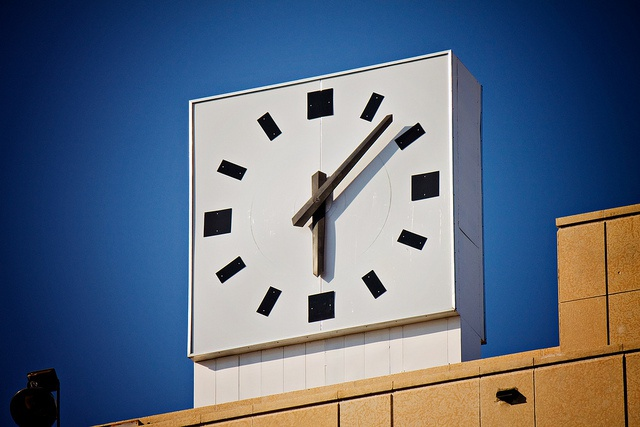Describe the objects in this image and their specific colors. I can see a clock in black, lightgray, and gray tones in this image. 